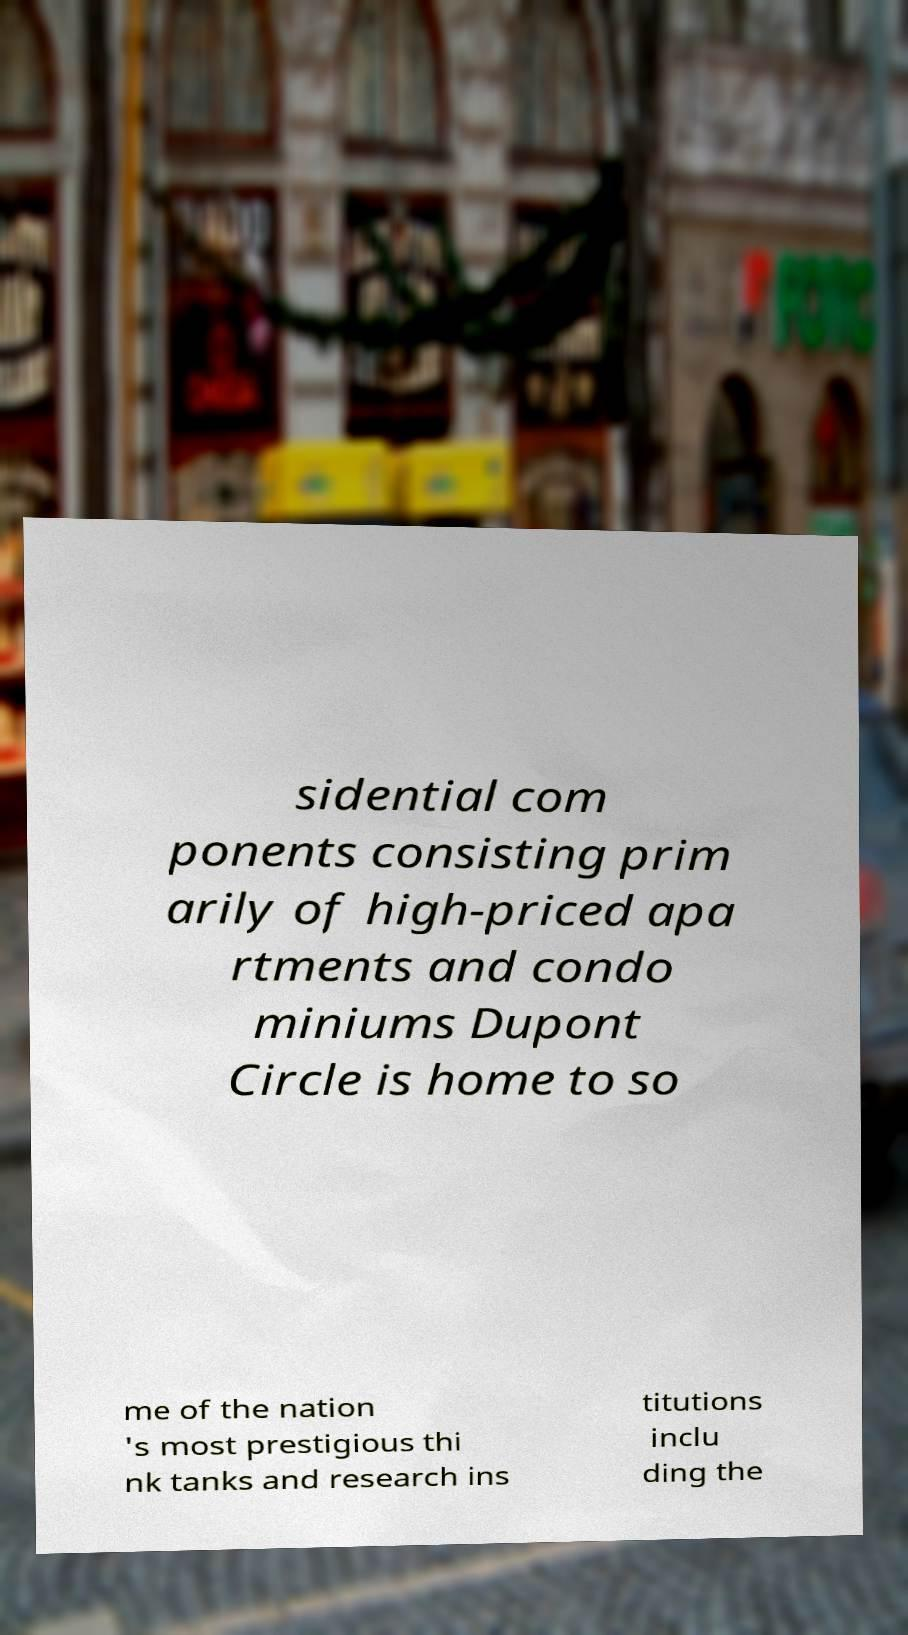Can you accurately transcribe the text from the provided image for me? sidential com ponents consisting prim arily of high-priced apa rtments and condo miniums Dupont Circle is home to so me of the nation 's most prestigious thi nk tanks and research ins titutions inclu ding the 